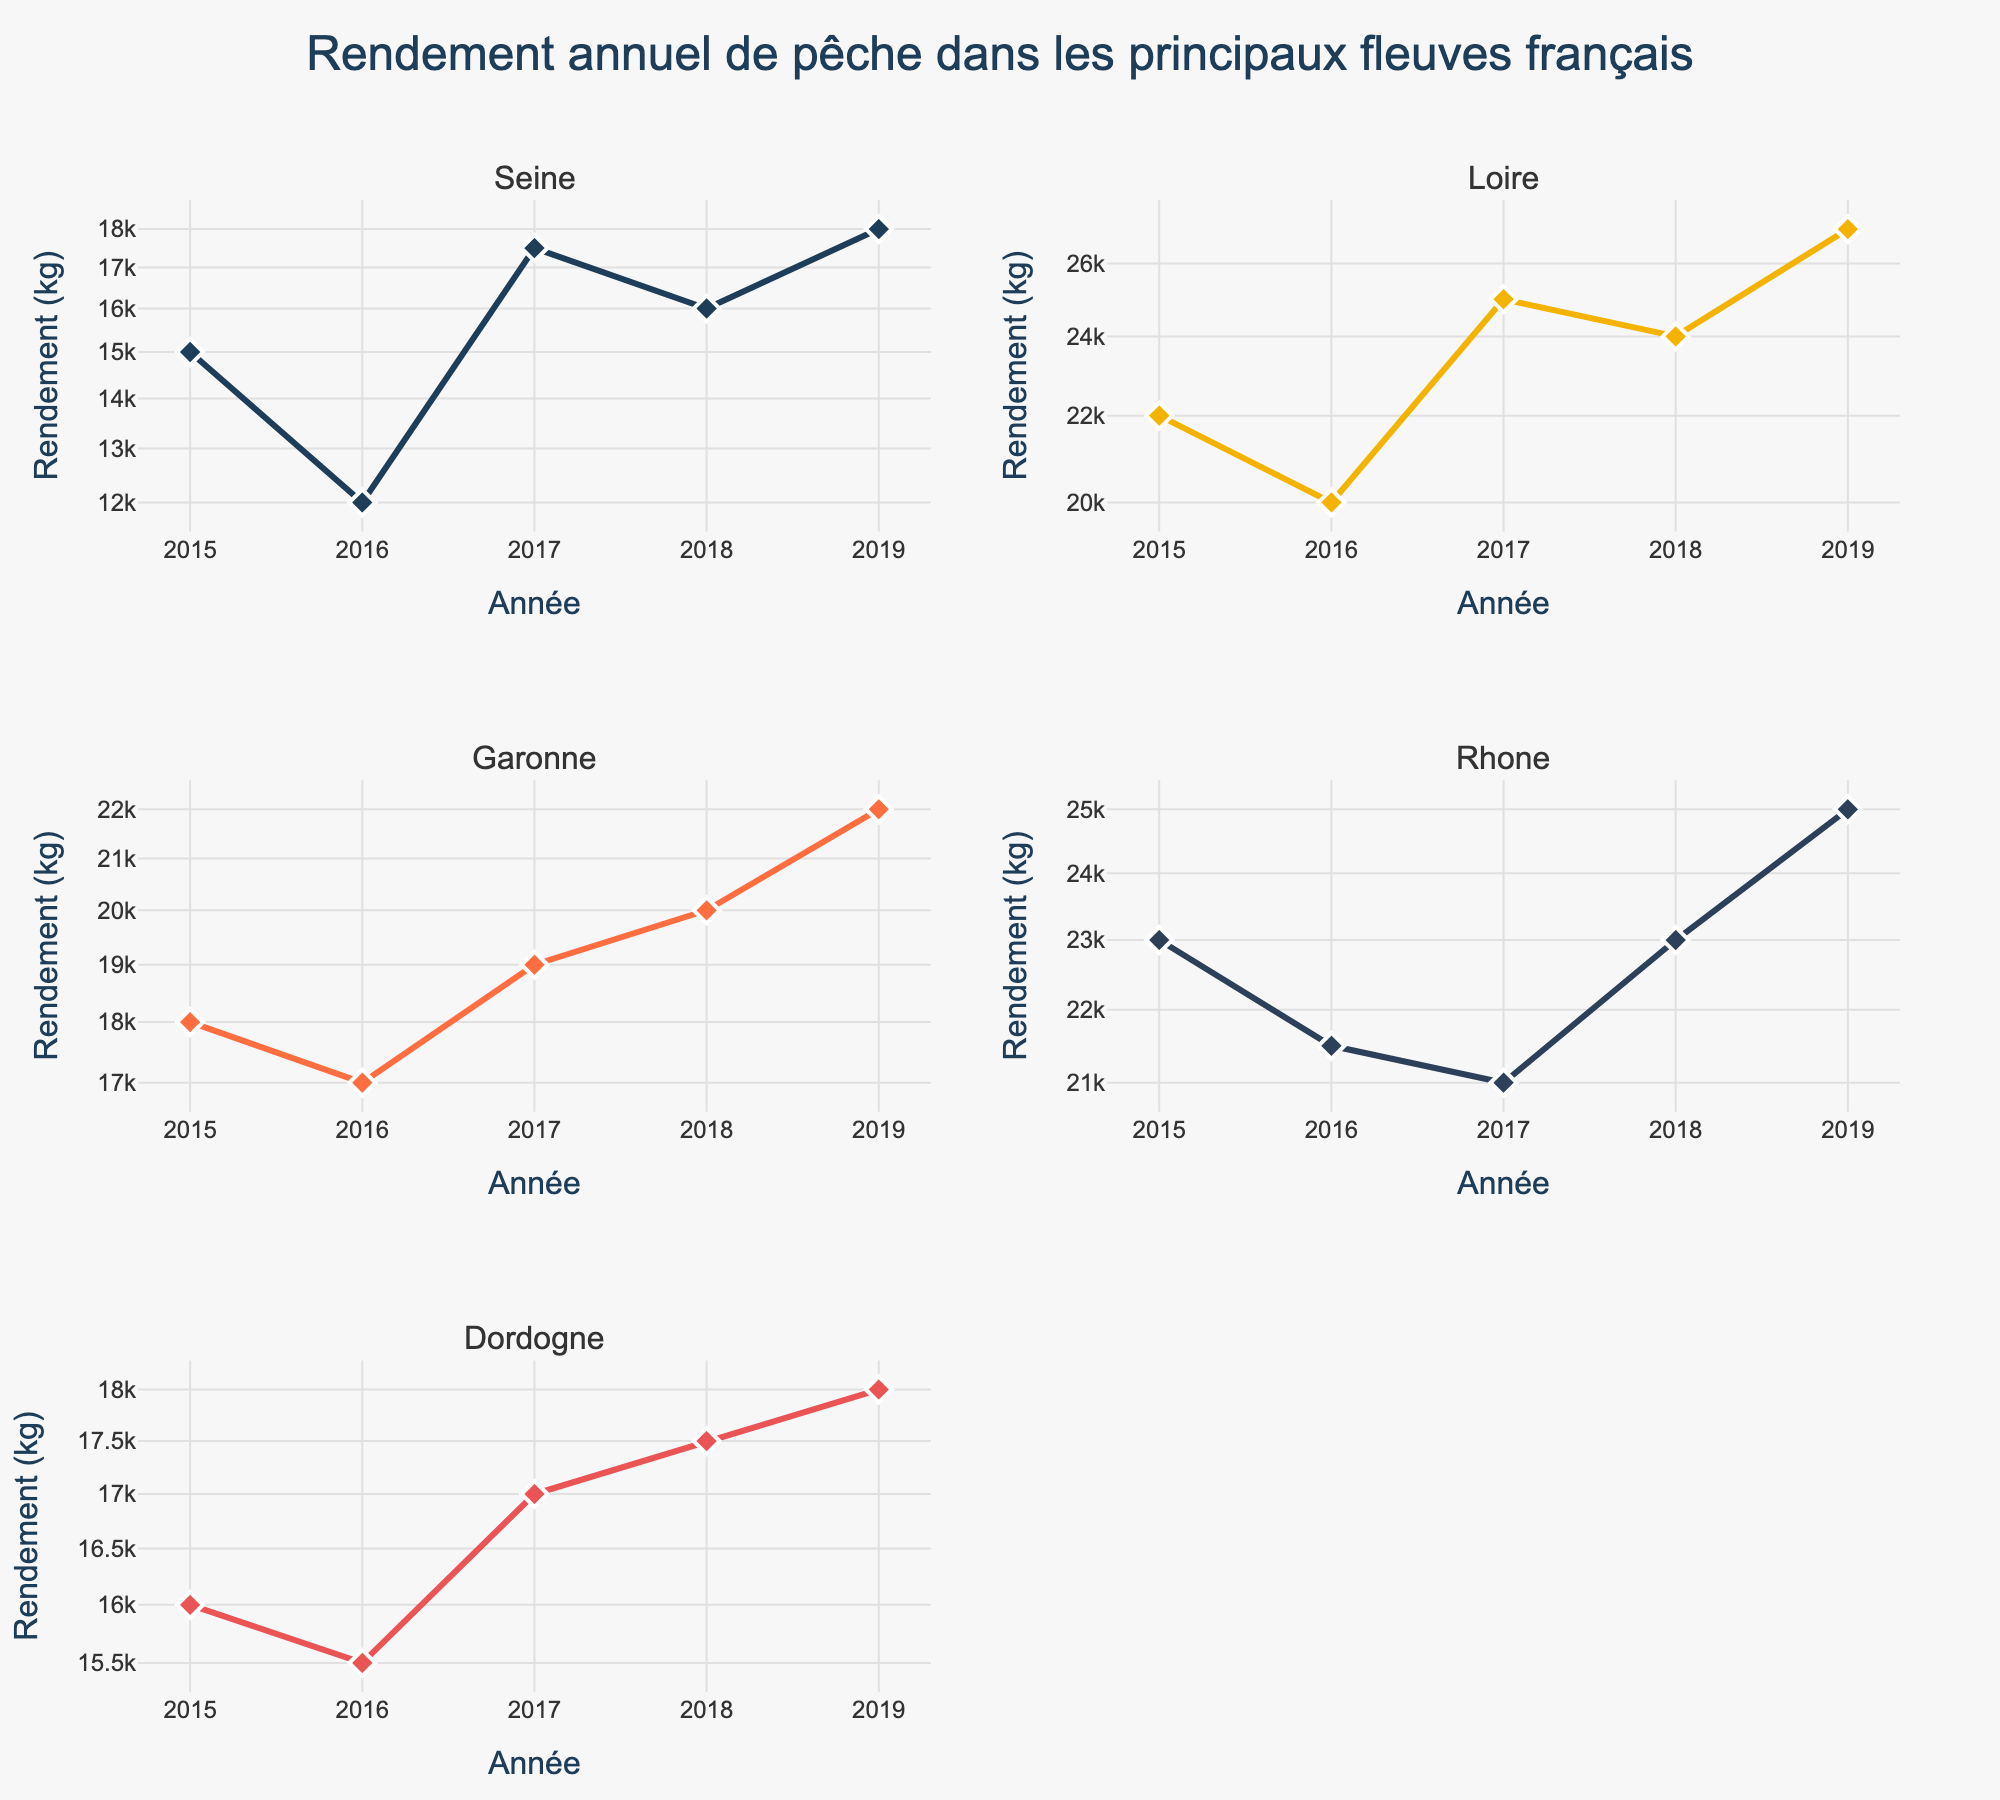Which river had the lowest fishing yield in 2019? Look for the subplot showing data for 2019 across all rivers and find the lowest value on the vertical axis. The Seine in Ile-de-France had the lowest fishing yield in 2019, which was 18,000 kg.
Answer: Seine How many regions are represented in the subplots? Count the unique regions in the subplot titles. The subplots display data for five rivers, each in a unique region.
Answer: 5 Which region showed a continuous increase in fishing yield from 2015 to 2019? Examine the trend lines in all subplots. The Loire in Central France shows a continuous increase in fishing yield from 2015 (22,000 kg) to 2019 (27,000 kg).
Answer: Central France What is the title of the entire figure? Refer to the centralized multi-line title at the top of the plot. The title is "Rendement annuel de pêche dans les principaux fleuves français".
Answer: Rendement annuel de pêche dans les principaux fleuves français What was the difference in fishing yield between the Rhone in Southeast France and the Dordogne in Southwest France in 2017? Find the points corresponding to 2017 on both the Rhone and the Dordogne subplots. The Rhone had 21,000 kg and the Dordogne had 17,000 kg, resulting in a difference of 4,000 kg.
Answer: 4,000 kg Among the rivers represented, which one showed the highest yield variation between any two years? Identify the rivers with significant changes by comparing the highest and lowest points for each river. The Loire in Central France varied from 20,000 kg in 2016 to 27,000 kg in 2019, a variation of 7,000 kg.
Answer: Loire Which year generally had the least variance in fishing yield across all rivers? Assess the vertical spread of data points for each year in each subplot. Estimate the difference between the maximum and minimum yields for each year across all subplots. Both 2016 and 2017 show relatively less spread but lies close on absolute scale.
Answer: 2016/2017 